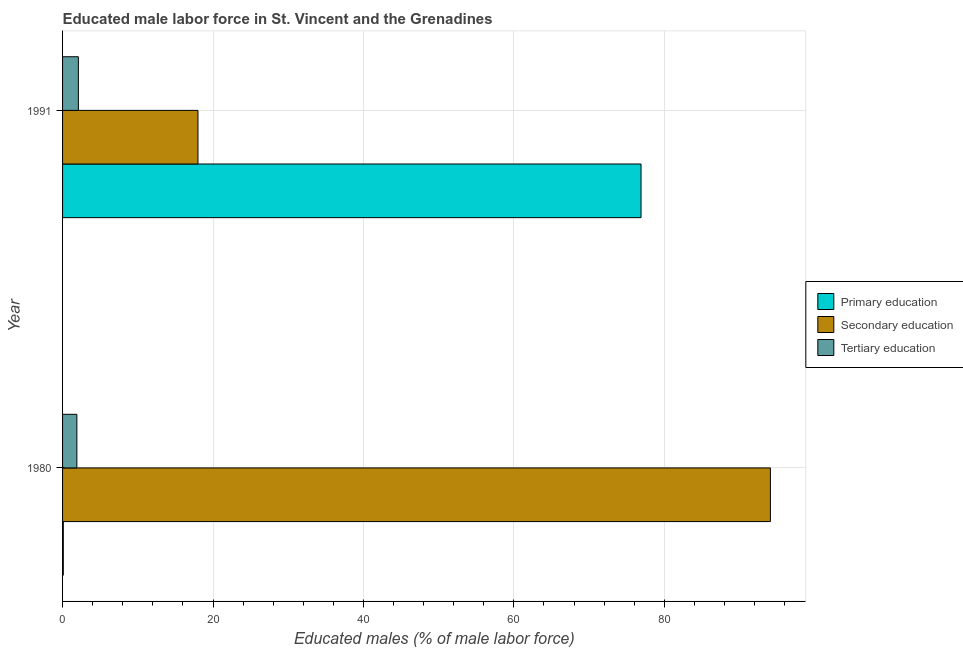How many different coloured bars are there?
Provide a short and direct response. 3. What is the label of the 1st group of bars from the top?
Offer a very short reply. 1991. What is the percentage of male labor force who received tertiary education in 1991?
Keep it short and to the point. 2.1. Across all years, what is the maximum percentage of male labor force who received tertiary education?
Provide a short and direct response. 2.1. Across all years, what is the minimum percentage of male labor force who received primary education?
Give a very brief answer. 0.1. In which year was the percentage of male labor force who received tertiary education minimum?
Offer a terse response. 1980. What is the total percentage of male labor force who received secondary education in the graph?
Your answer should be very brief. 112.1. What is the difference between the percentage of male labor force who received secondary education in 1980 and that in 1991?
Your response must be concise. 76.1. What is the difference between the percentage of male labor force who received secondary education in 1991 and the percentage of male labor force who received tertiary education in 1980?
Your answer should be very brief. 16.1. In the year 1991, what is the difference between the percentage of male labor force who received primary education and percentage of male labor force who received tertiary education?
Give a very brief answer. 74.8. What is the ratio of the percentage of male labor force who received tertiary education in 1980 to that in 1991?
Offer a terse response. 0.91. In how many years, is the percentage of male labor force who received tertiary education greater than the average percentage of male labor force who received tertiary education taken over all years?
Your answer should be compact. 1. What does the 1st bar from the top in 1980 represents?
Your answer should be compact. Tertiary education. What does the 1st bar from the bottom in 1991 represents?
Ensure brevity in your answer.  Primary education. How many bars are there?
Your response must be concise. 6. Are all the bars in the graph horizontal?
Keep it short and to the point. Yes. How many years are there in the graph?
Give a very brief answer. 2. What is the difference between two consecutive major ticks on the X-axis?
Your response must be concise. 20. Are the values on the major ticks of X-axis written in scientific E-notation?
Offer a terse response. No. Does the graph contain any zero values?
Offer a very short reply. No. Where does the legend appear in the graph?
Your answer should be compact. Center right. How many legend labels are there?
Your answer should be very brief. 3. What is the title of the graph?
Your answer should be compact. Educated male labor force in St. Vincent and the Grenadines. What is the label or title of the X-axis?
Keep it short and to the point. Educated males (% of male labor force). What is the Educated males (% of male labor force) in Primary education in 1980?
Keep it short and to the point. 0.1. What is the Educated males (% of male labor force) in Secondary education in 1980?
Your answer should be very brief. 94.1. What is the Educated males (% of male labor force) in Tertiary education in 1980?
Ensure brevity in your answer.  1.9. What is the Educated males (% of male labor force) in Primary education in 1991?
Give a very brief answer. 76.9. What is the Educated males (% of male labor force) of Secondary education in 1991?
Offer a very short reply. 18. What is the Educated males (% of male labor force) of Tertiary education in 1991?
Offer a terse response. 2.1. Across all years, what is the maximum Educated males (% of male labor force) in Primary education?
Provide a short and direct response. 76.9. Across all years, what is the maximum Educated males (% of male labor force) of Secondary education?
Provide a succinct answer. 94.1. Across all years, what is the maximum Educated males (% of male labor force) of Tertiary education?
Provide a short and direct response. 2.1. Across all years, what is the minimum Educated males (% of male labor force) of Primary education?
Your answer should be compact. 0.1. Across all years, what is the minimum Educated males (% of male labor force) of Tertiary education?
Make the answer very short. 1.9. What is the total Educated males (% of male labor force) of Secondary education in the graph?
Provide a succinct answer. 112.1. What is the total Educated males (% of male labor force) in Tertiary education in the graph?
Your answer should be very brief. 4. What is the difference between the Educated males (% of male labor force) of Primary education in 1980 and that in 1991?
Give a very brief answer. -76.8. What is the difference between the Educated males (% of male labor force) of Secondary education in 1980 and that in 1991?
Provide a succinct answer. 76.1. What is the difference between the Educated males (% of male labor force) of Tertiary education in 1980 and that in 1991?
Keep it short and to the point. -0.2. What is the difference between the Educated males (% of male labor force) in Primary education in 1980 and the Educated males (% of male labor force) in Secondary education in 1991?
Offer a terse response. -17.9. What is the difference between the Educated males (% of male labor force) in Secondary education in 1980 and the Educated males (% of male labor force) in Tertiary education in 1991?
Your response must be concise. 92. What is the average Educated males (% of male labor force) in Primary education per year?
Your answer should be very brief. 38.5. What is the average Educated males (% of male labor force) of Secondary education per year?
Offer a very short reply. 56.05. What is the average Educated males (% of male labor force) of Tertiary education per year?
Provide a short and direct response. 2. In the year 1980, what is the difference between the Educated males (% of male labor force) in Primary education and Educated males (% of male labor force) in Secondary education?
Provide a short and direct response. -94. In the year 1980, what is the difference between the Educated males (% of male labor force) in Secondary education and Educated males (% of male labor force) in Tertiary education?
Offer a very short reply. 92.2. In the year 1991, what is the difference between the Educated males (% of male labor force) in Primary education and Educated males (% of male labor force) in Secondary education?
Provide a short and direct response. 58.9. In the year 1991, what is the difference between the Educated males (% of male labor force) in Primary education and Educated males (% of male labor force) in Tertiary education?
Offer a very short reply. 74.8. What is the ratio of the Educated males (% of male labor force) of Primary education in 1980 to that in 1991?
Make the answer very short. 0. What is the ratio of the Educated males (% of male labor force) of Secondary education in 1980 to that in 1991?
Offer a terse response. 5.23. What is the ratio of the Educated males (% of male labor force) in Tertiary education in 1980 to that in 1991?
Offer a very short reply. 0.9. What is the difference between the highest and the second highest Educated males (% of male labor force) of Primary education?
Offer a very short reply. 76.8. What is the difference between the highest and the second highest Educated males (% of male labor force) in Secondary education?
Your answer should be compact. 76.1. What is the difference between the highest and the lowest Educated males (% of male labor force) of Primary education?
Your answer should be compact. 76.8. What is the difference between the highest and the lowest Educated males (% of male labor force) of Secondary education?
Keep it short and to the point. 76.1. What is the difference between the highest and the lowest Educated males (% of male labor force) in Tertiary education?
Your answer should be very brief. 0.2. 